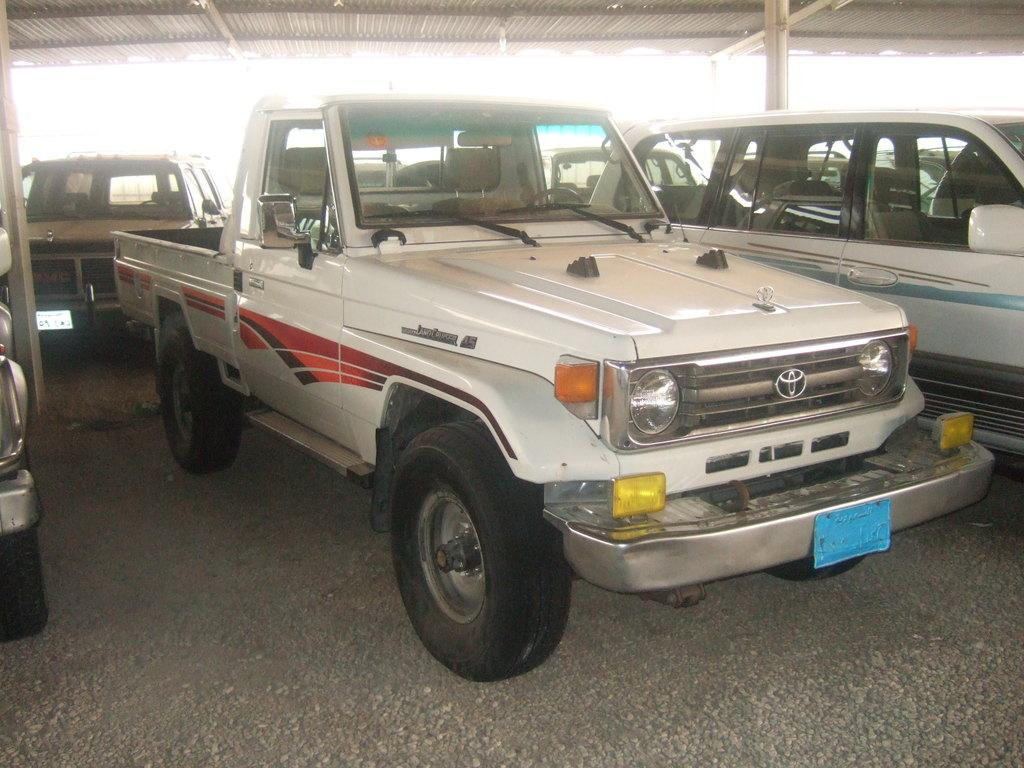What type of structure can be seen in the image? There is a shed in the image. What is located under the shed? Vehicles are present on the ground under the shed. What type of lamp is hanging from the ceiling of the shed in the image? There is no lamp present in the image; it only shows a shed and vehicles underneath it. 